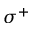Convert formula to latex. <formula><loc_0><loc_0><loc_500><loc_500>\sigma ^ { + }</formula> 